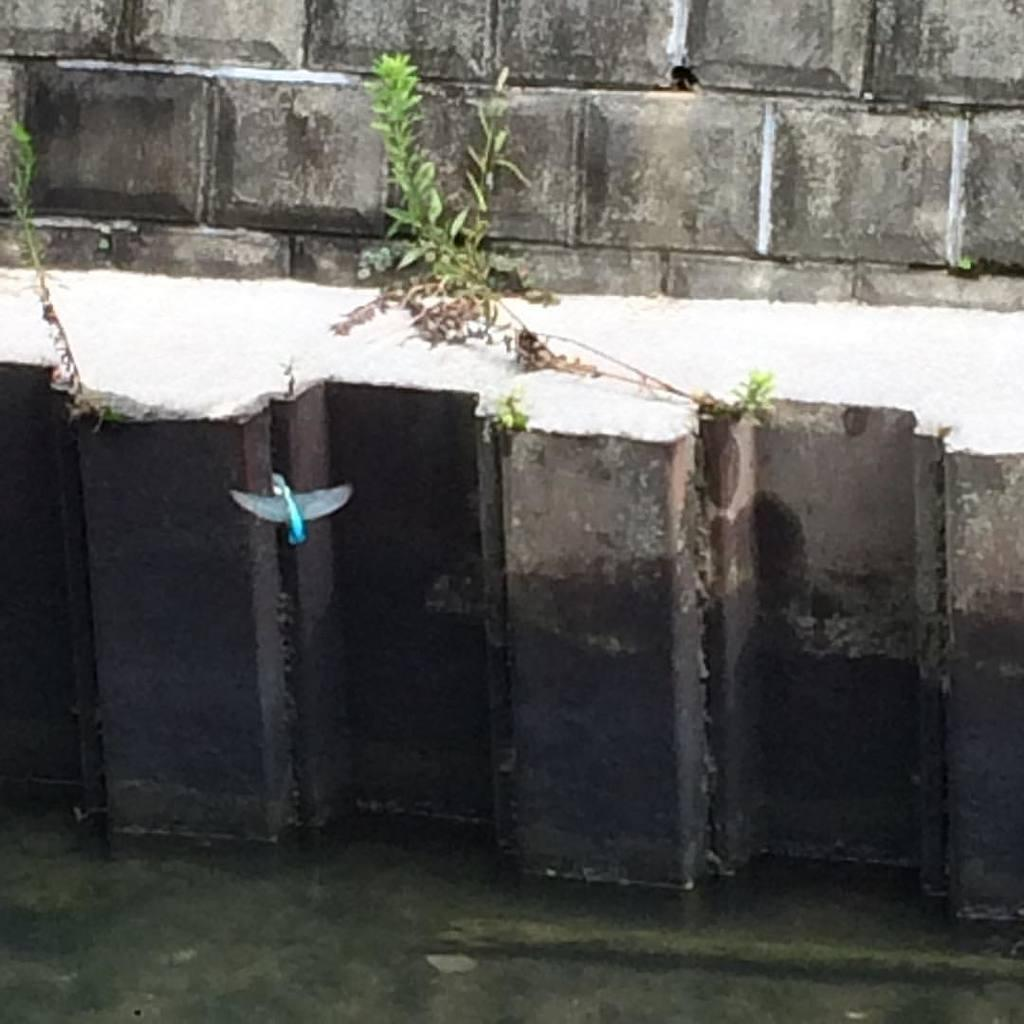What color is the object in the image? The object in the image is blue. What type of vegetation can be seen in the image? There is grass in the center of the image. What can be seen in the background of the image? There is a wall visible in the background of the image. What type of coil is present in the image? There is no coil present in the image. What type of badge can be seen on the grass in the image? There is no badge present in the image. 